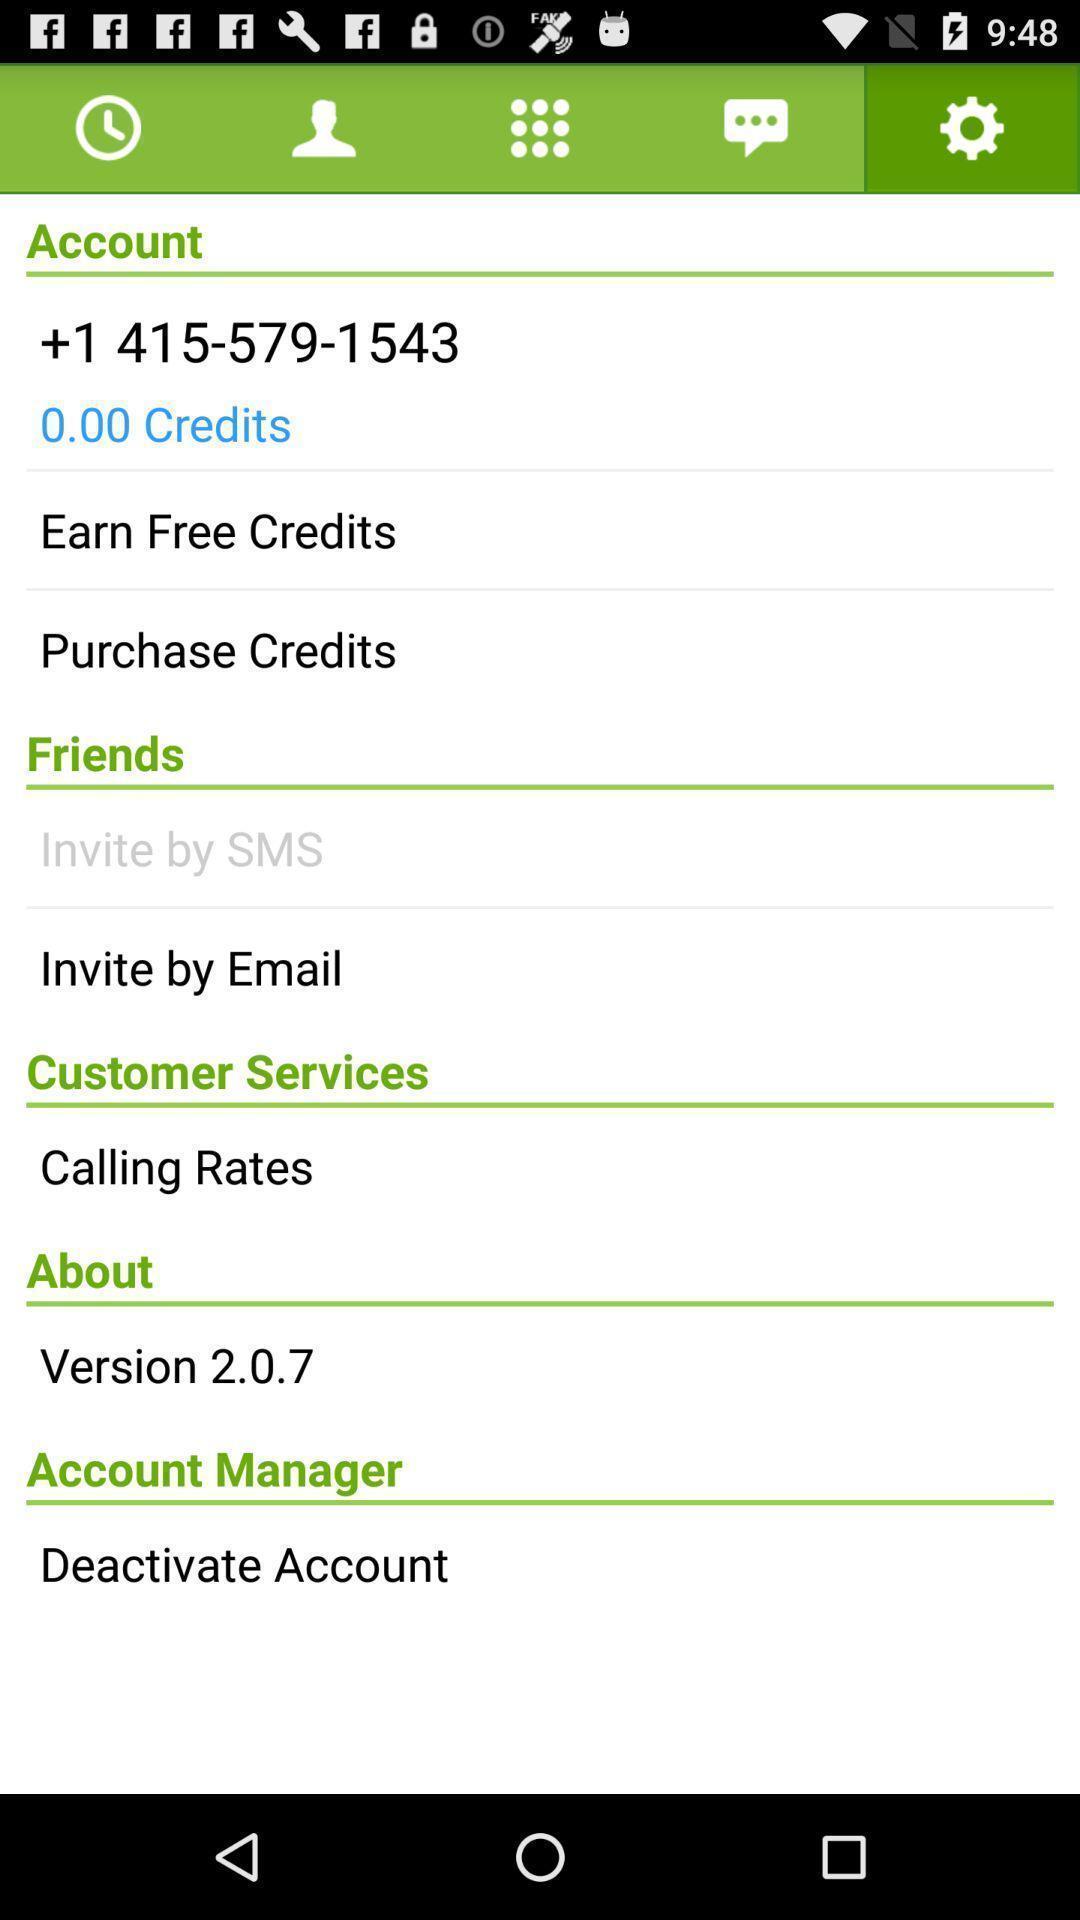Explain the elements present in this screenshot. Page showing details of a phone number on a device. 